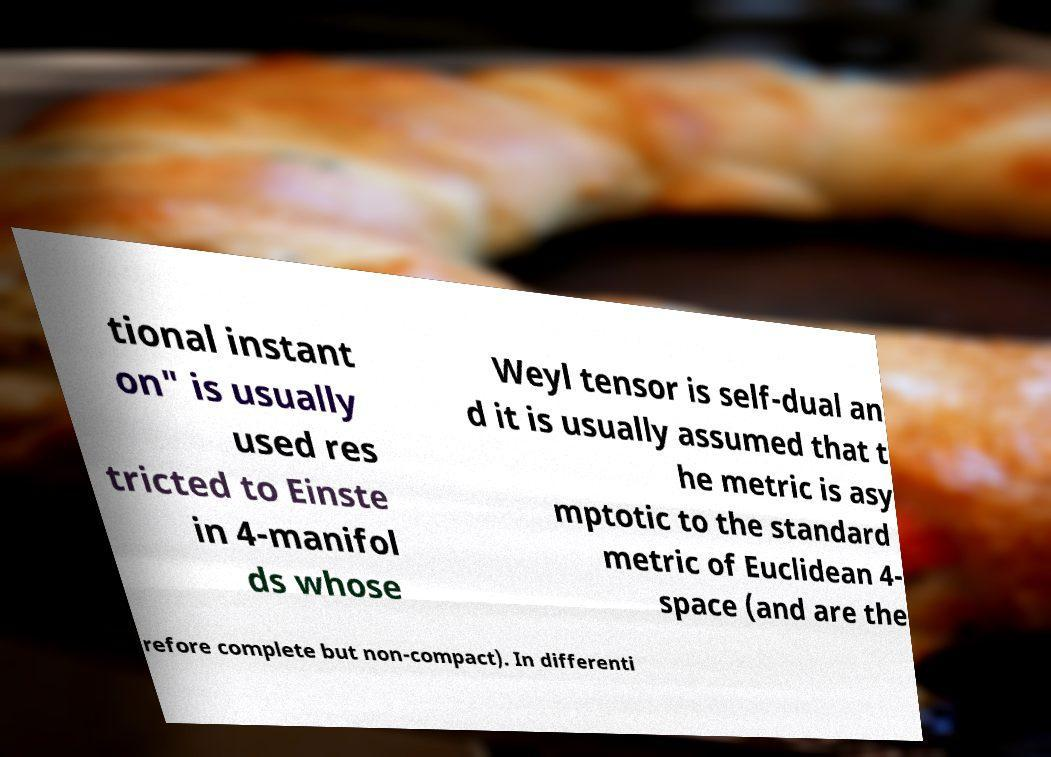What messages or text are displayed in this image? I need them in a readable, typed format. tional instant on" is usually used res tricted to Einste in 4-manifol ds whose Weyl tensor is self-dual an d it is usually assumed that t he metric is asy mptotic to the standard metric of Euclidean 4- space (and are the refore complete but non-compact). In differenti 